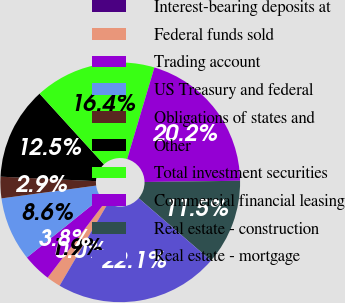<chart> <loc_0><loc_0><loc_500><loc_500><pie_chart><fcel>Interest-bearing deposits at<fcel>Federal funds sold<fcel>Trading account<fcel>US Treasury and federal<fcel>Obligations of states and<fcel>Other<fcel>Total investment securities<fcel>Commercial financial leasing<fcel>Real estate - construction<fcel>Real estate - mortgage<nl><fcel>0.0%<fcel>1.92%<fcel>3.85%<fcel>8.65%<fcel>2.89%<fcel>12.5%<fcel>16.35%<fcel>20.19%<fcel>11.54%<fcel>22.11%<nl></chart> 